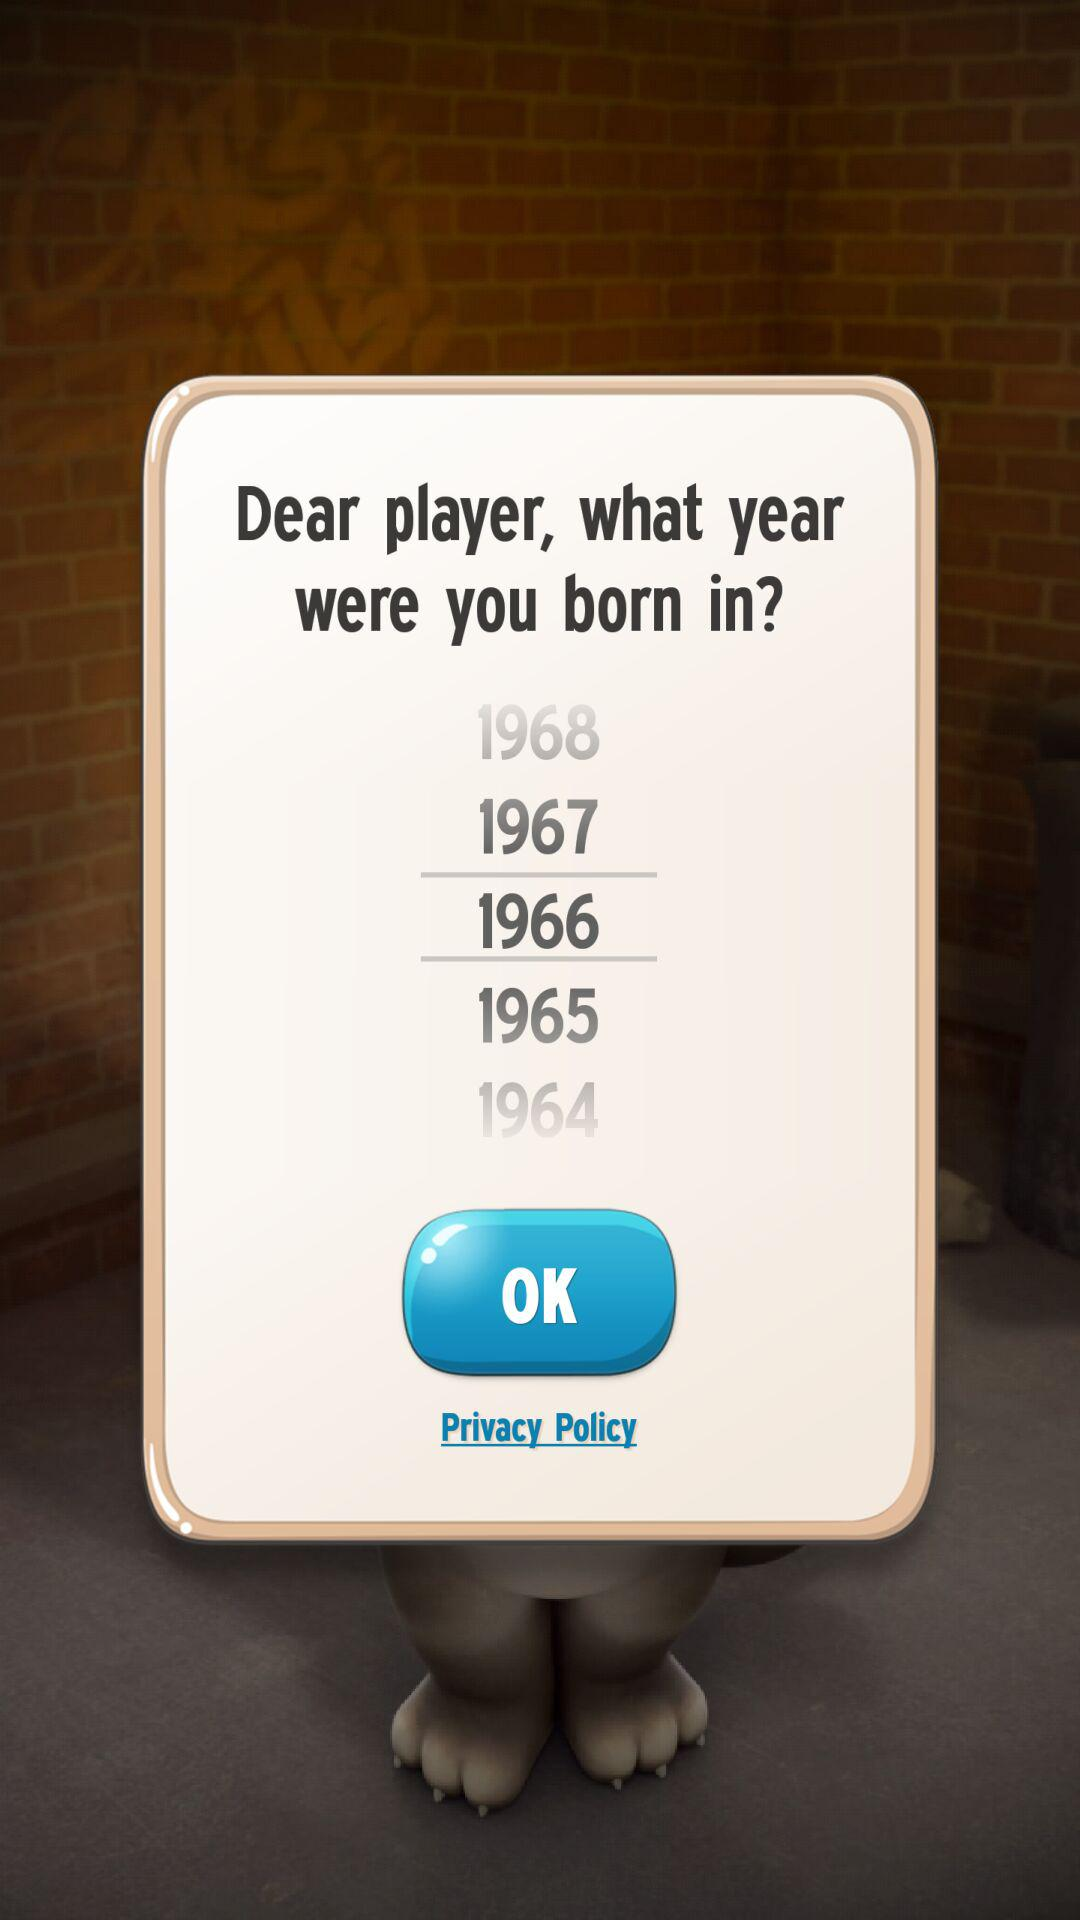How many years are between the earliest and latest birth years?
Answer the question using a single word or phrase. 4 